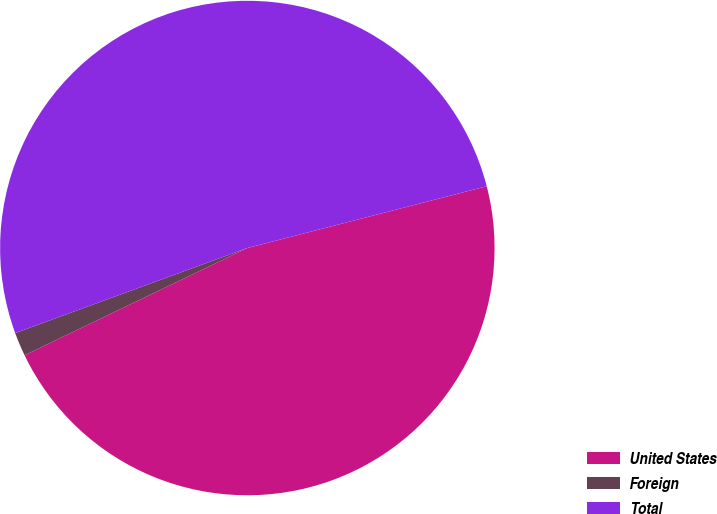<chart> <loc_0><loc_0><loc_500><loc_500><pie_chart><fcel>United States<fcel>Foreign<fcel>Total<nl><fcel>46.88%<fcel>1.55%<fcel>51.57%<nl></chart> 